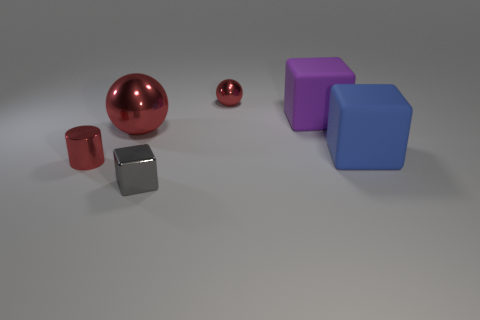What number of other objects are the same size as the gray object?
Offer a terse response. 2. There is a tiny red metal object that is right of the small red thing in front of the large blue matte object; is there a large shiny object that is behind it?
Provide a succinct answer. No. Is there anything else that is the same color as the big shiny sphere?
Your response must be concise. Yes. There is a ball to the right of the tiny gray shiny object; how big is it?
Provide a succinct answer. Small. There is a metal thing in front of the red thing that is in front of the red shiny ball that is left of the gray thing; what size is it?
Keep it short and to the point. Small. There is a big ball in front of the tiny red metallic object right of the metallic block; what is its color?
Give a very brief answer. Red. What is the material of the large purple thing that is the same shape as the small gray thing?
Provide a short and direct response. Rubber. Is there any other thing that has the same material as the big ball?
Give a very brief answer. Yes. Are there any gray cubes to the left of the small gray metallic cube?
Offer a terse response. No. What number of tiny purple metallic cubes are there?
Provide a short and direct response. 0. 